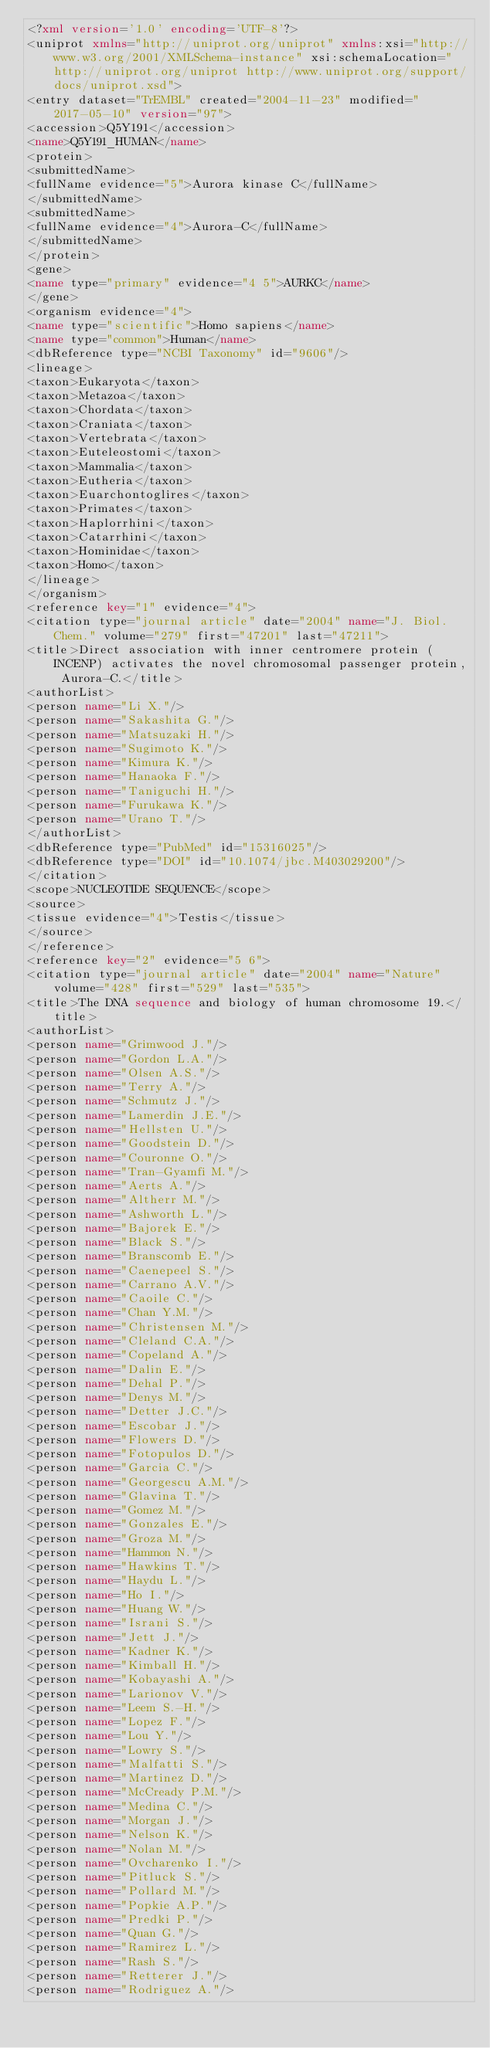Convert code to text. <code><loc_0><loc_0><loc_500><loc_500><_XML_><?xml version='1.0' encoding='UTF-8'?>
<uniprot xmlns="http://uniprot.org/uniprot" xmlns:xsi="http://www.w3.org/2001/XMLSchema-instance" xsi:schemaLocation="http://uniprot.org/uniprot http://www.uniprot.org/support/docs/uniprot.xsd">
<entry dataset="TrEMBL" created="2004-11-23" modified="2017-05-10" version="97">
<accession>Q5Y191</accession>
<name>Q5Y191_HUMAN</name>
<protein>
<submittedName>
<fullName evidence="5">Aurora kinase C</fullName>
</submittedName>
<submittedName>
<fullName evidence="4">Aurora-C</fullName>
</submittedName>
</protein>
<gene>
<name type="primary" evidence="4 5">AURKC</name>
</gene>
<organism evidence="4">
<name type="scientific">Homo sapiens</name>
<name type="common">Human</name>
<dbReference type="NCBI Taxonomy" id="9606"/>
<lineage>
<taxon>Eukaryota</taxon>
<taxon>Metazoa</taxon>
<taxon>Chordata</taxon>
<taxon>Craniata</taxon>
<taxon>Vertebrata</taxon>
<taxon>Euteleostomi</taxon>
<taxon>Mammalia</taxon>
<taxon>Eutheria</taxon>
<taxon>Euarchontoglires</taxon>
<taxon>Primates</taxon>
<taxon>Haplorrhini</taxon>
<taxon>Catarrhini</taxon>
<taxon>Hominidae</taxon>
<taxon>Homo</taxon>
</lineage>
</organism>
<reference key="1" evidence="4">
<citation type="journal article" date="2004" name="J. Biol. Chem." volume="279" first="47201" last="47211">
<title>Direct association with inner centromere protein (INCENP) activates the novel chromosomal passenger protein, Aurora-C.</title>
<authorList>
<person name="Li X."/>
<person name="Sakashita G."/>
<person name="Matsuzaki H."/>
<person name="Sugimoto K."/>
<person name="Kimura K."/>
<person name="Hanaoka F."/>
<person name="Taniguchi H."/>
<person name="Furukawa K."/>
<person name="Urano T."/>
</authorList>
<dbReference type="PubMed" id="15316025"/>
<dbReference type="DOI" id="10.1074/jbc.M403029200"/>
</citation>
<scope>NUCLEOTIDE SEQUENCE</scope>
<source>
<tissue evidence="4">Testis</tissue>
</source>
</reference>
<reference key="2" evidence="5 6">
<citation type="journal article" date="2004" name="Nature" volume="428" first="529" last="535">
<title>The DNA sequence and biology of human chromosome 19.</title>
<authorList>
<person name="Grimwood J."/>
<person name="Gordon L.A."/>
<person name="Olsen A.S."/>
<person name="Terry A."/>
<person name="Schmutz J."/>
<person name="Lamerdin J.E."/>
<person name="Hellsten U."/>
<person name="Goodstein D."/>
<person name="Couronne O."/>
<person name="Tran-Gyamfi M."/>
<person name="Aerts A."/>
<person name="Altherr M."/>
<person name="Ashworth L."/>
<person name="Bajorek E."/>
<person name="Black S."/>
<person name="Branscomb E."/>
<person name="Caenepeel S."/>
<person name="Carrano A.V."/>
<person name="Caoile C."/>
<person name="Chan Y.M."/>
<person name="Christensen M."/>
<person name="Cleland C.A."/>
<person name="Copeland A."/>
<person name="Dalin E."/>
<person name="Dehal P."/>
<person name="Denys M."/>
<person name="Detter J.C."/>
<person name="Escobar J."/>
<person name="Flowers D."/>
<person name="Fotopulos D."/>
<person name="Garcia C."/>
<person name="Georgescu A.M."/>
<person name="Glavina T."/>
<person name="Gomez M."/>
<person name="Gonzales E."/>
<person name="Groza M."/>
<person name="Hammon N."/>
<person name="Hawkins T."/>
<person name="Haydu L."/>
<person name="Ho I."/>
<person name="Huang W."/>
<person name="Israni S."/>
<person name="Jett J."/>
<person name="Kadner K."/>
<person name="Kimball H."/>
<person name="Kobayashi A."/>
<person name="Larionov V."/>
<person name="Leem S.-H."/>
<person name="Lopez F."/>
<person name="Lou Y."/>
<person name="Lowry S."/>
<person name="Malfatti S."/>
<person name="Martinez D."/>
<person name="McCready P.M."/>
<person name="Medina C."/>
<person name="Morgan J."/>
<person name="Nelson K."/>
<person name="Nolan M."/>
<person name="Ovcharenko I."/>
<person name="Pitluck S."/>
<person name="Pollard M."/>
<person name="Popkie A.P."/>
<person name="Predki P."/>
<person name="Quan G."/>
<person name="Ramirez L."/>
<person name="Rash S."/>
<person name="Retterer J."/>
<person name="Rodriguez A."/></code> 